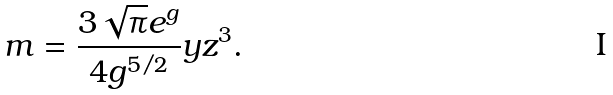<formula> <loc_0><loc_0><loc_500><loc_500>m = \frac { 3 \sqrt { \pi } e ^ { g } } { 4 g ^ { 5 / 2 } } y z ^ { 3 } .</formula> 